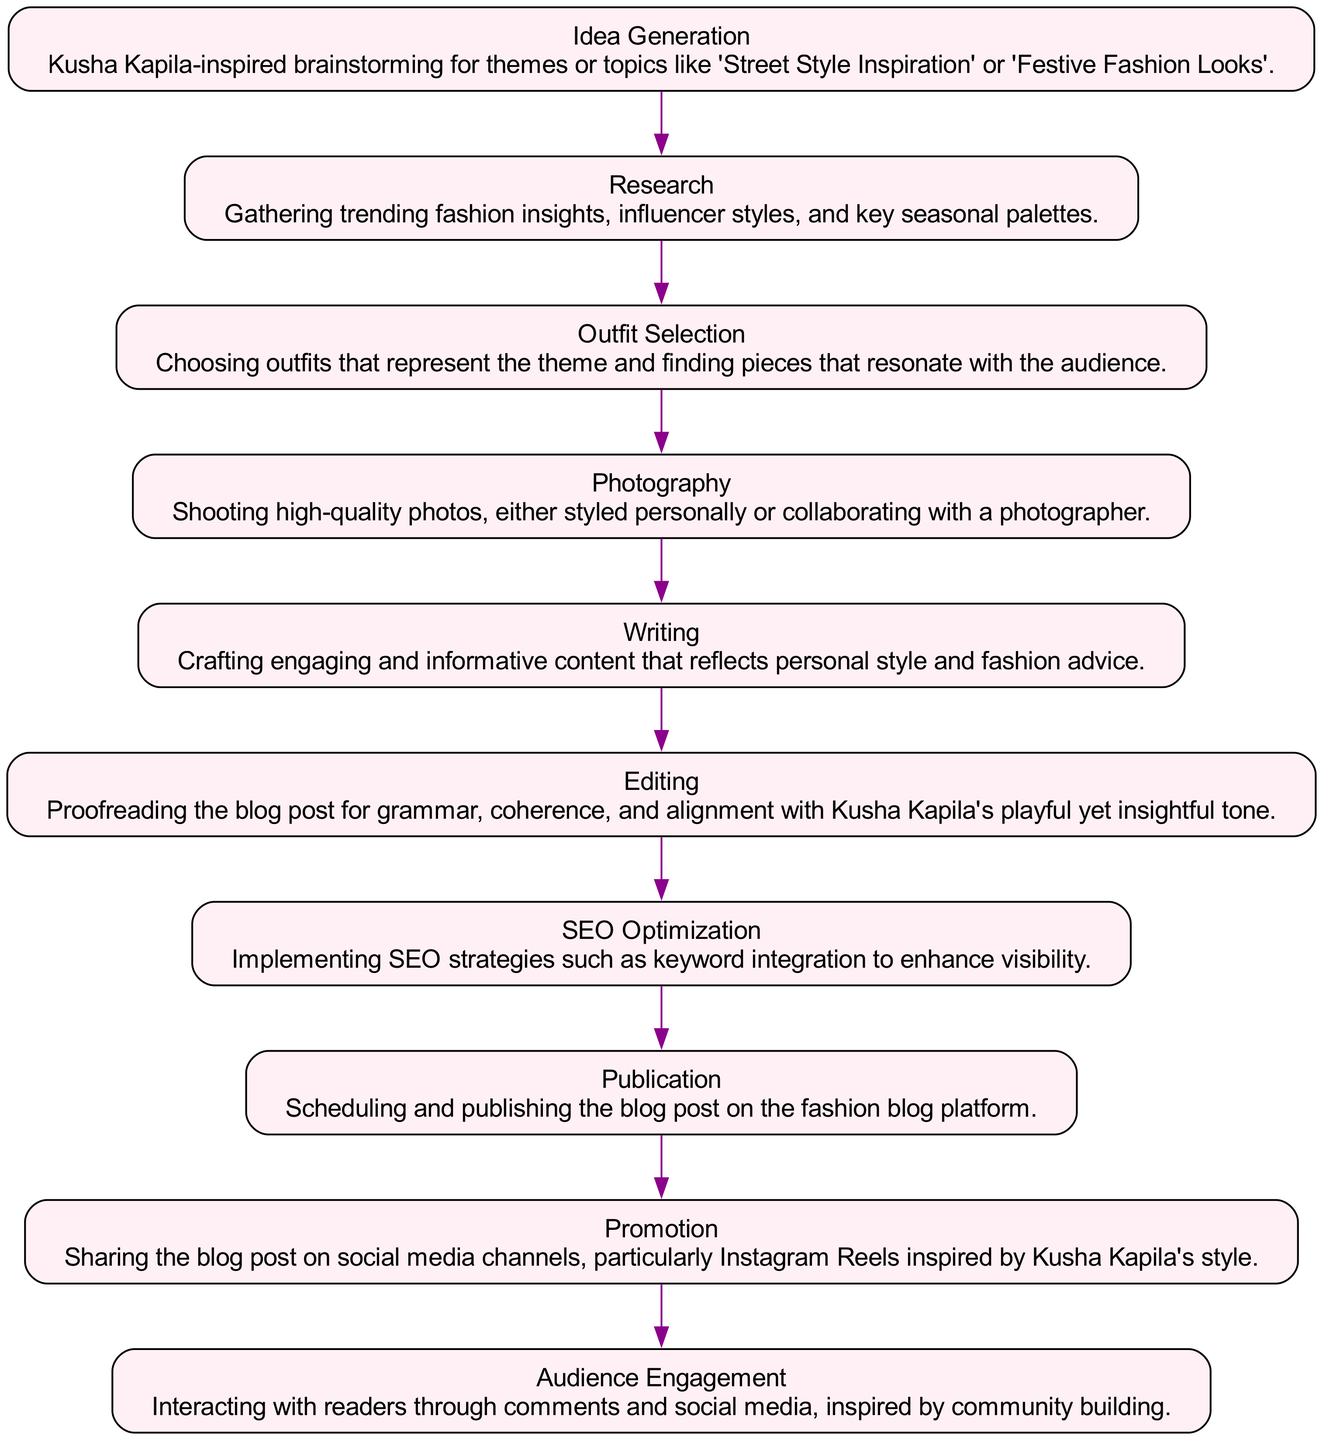What is the first step in creating a fashion blog post? The first step mentioned in the diagram is "Idea Generation," which involves brainstorming themes or topics inspired by Kusha Kapila.
Answer: Idea Generation How many steps are involved in the process? By counting the distinct steps listed in the diagram, we see there are ten steps involved in the creation process, from Idea Generation to Audience Engagement.
Answer: Ten What comes immediately after Research? According to the flow of the diagram, "Outfit Selection" follows "Research," indicating the sequence of steps in creating the fashion blog post.
Answer: Outfit Selection What step follows SEO Optimization? The step that follows "SEO Optimization" is "Publication," which involves scheduling and publishing the blog post online.
Answer: Publication Which step emphasizes community interaction? The final step, "Audience Engagement," places importance on interacting with readers, showcasing how community building is emphasized.
Answer: Audience Engagement How many edges connect the steps in the diagram? Each step (except the first) has an edge connecting it to the previous step. With ten steps, there are nine edges connecting them.
Answer: Nine What thematic inspiration is used during the processes? The thematic inspiration for the processes is primarily drawn from Kusha Kapila, as seen in the descriptions of several steps.
Answer: Kusha Kapila Which step is focused on visual content creation? "Photography" is the step dedicated to creating high-quality visuals for the blog post.
Answer: Photography What is the last step in the sequence? The last step in the sequence is "Audience Engagement," which focuses on interacting with readers following publication.
Answer: Audience Engagement 